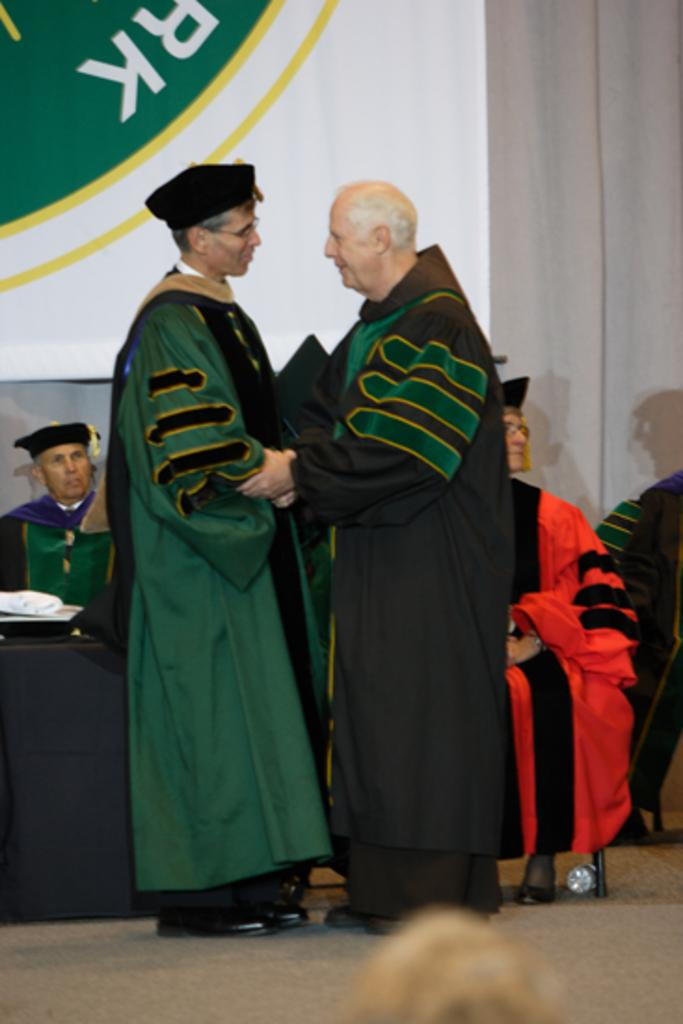How many people are in the image? There are two delegates in the image. What are the delegates doing in the image? The delegates are greeting each other. Can you describe the setting in the background of the image? There are people sitting on chairs in the background of the image. What type of rod is being used to control the current in the image? There is no rod or current present in the image; it features two delegates greeting each other. What disease is being discussed by the delegates in the image? There is no indication in the image that the delegates are discussing any disease. 